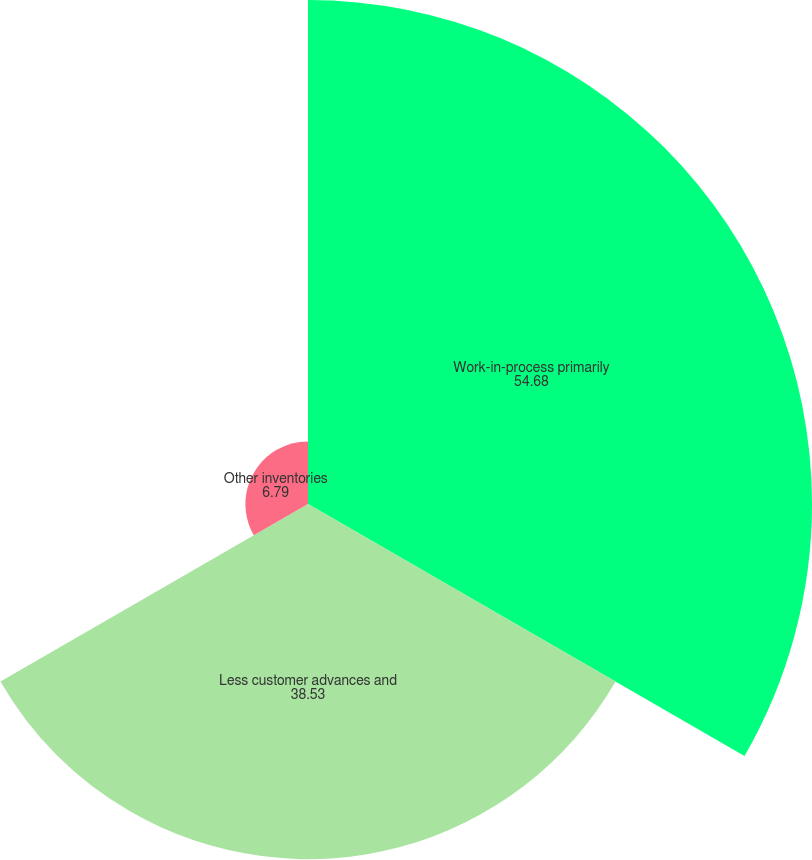Convert chart to OTSL. <chart><loc_0><loc_0><loc_500><loc_500><pie_chart><fcel>Work-in-process primarily<fcel>Less customer advances and<fcel>Other inventories<nl><fcel>54.68%<fcel>38.53%<fcel>6.79%<nl></chart> 